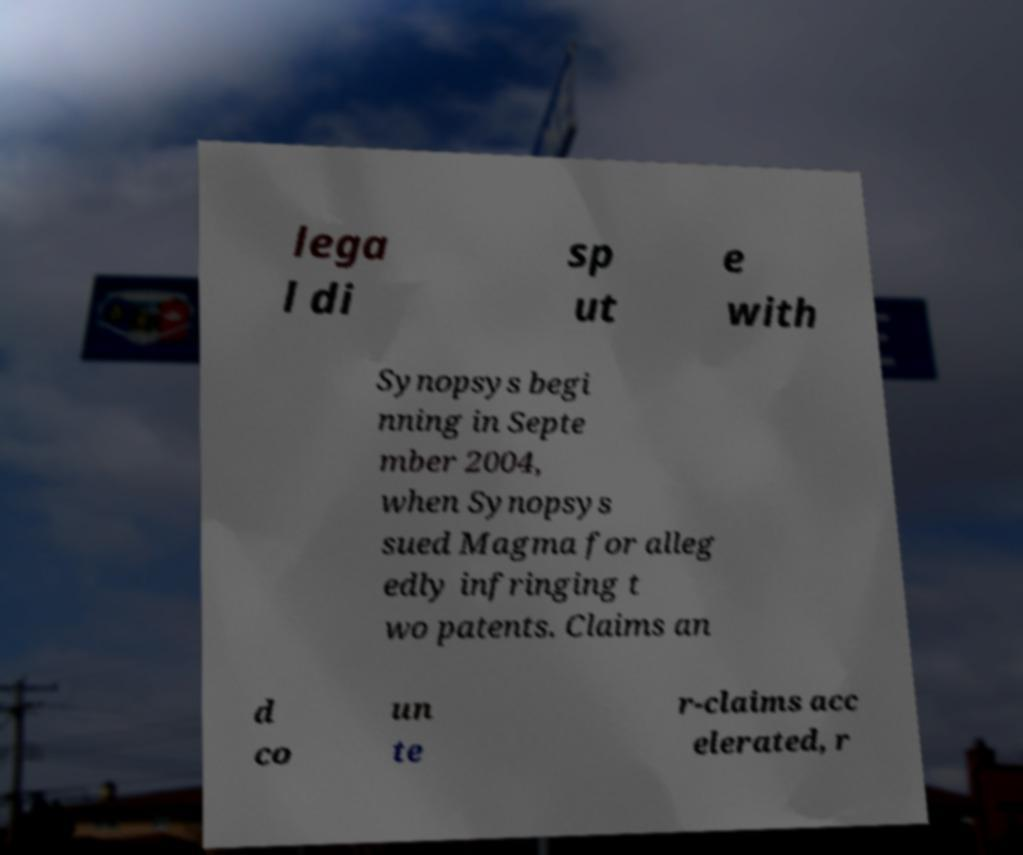Could you extract and type out the text from this image? lega l di sp ut e with Synopsys begi nning in Septe mber 2004, when Synopsys sued Magma for alleg edly infringing t wo patents. Claims an d co un te r-claims acc elerated, r 